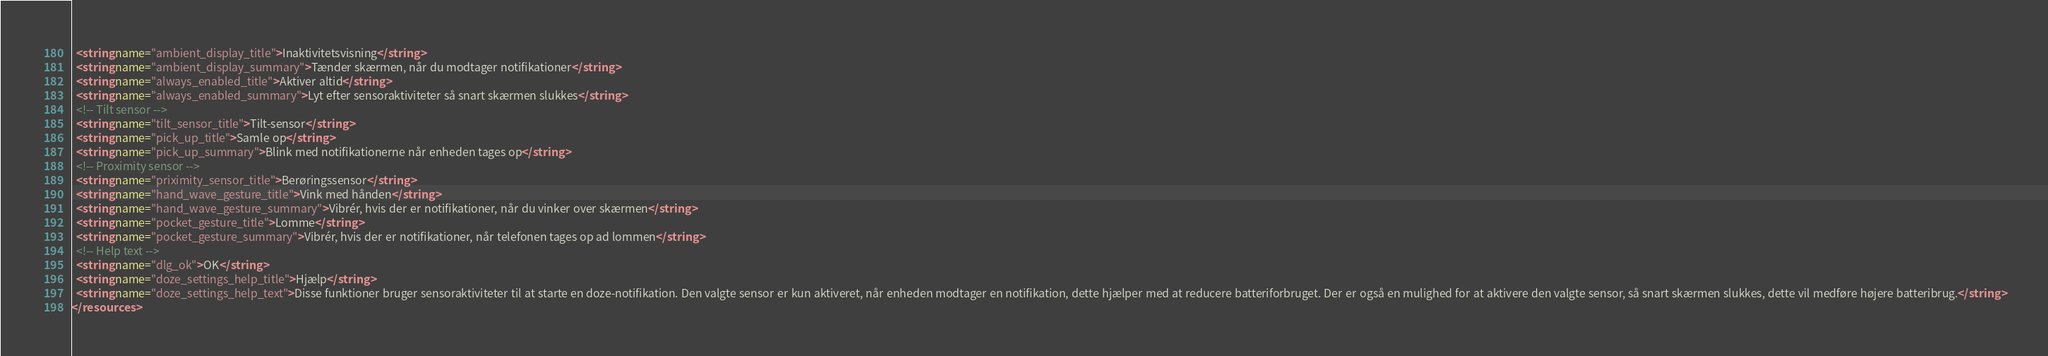Convert code to text. <code><loc_0><loc_0><loc_500><loc_500><_XML_>  <string name="ambient_display_title">Inaktivitetsvisning</string>
  <string name="ambient_display_summary">Tænder skærmen, når du modtager notifikationer</string>
  <string name="always_enabled_title">Aktiver altid</string>
  <string name="always_enabled_summary">Lyt efter sensoraktiviteter så snart skærmen slukkes</string>
  <!-- Tilt sensor -->
  <string name="tilt_sensor_title">Tilt-sensor</string>
  <string name="pick_up_title">Samle op</string>
  <string name="pick_up_summary">Blink med notifikationerne når enheden tages op</string>
  <!-- Proximity sensor -->
  <string name="priximity_sensor_title">Berøringssensor</string>
  <string name="hand_wave_gesture_title">Vink med hånden</string>
  <string name="hand_wave_gesture_summary">Vibrér, hvis der er notifikationer, når du vinker over skærmen</string>
  <string name="pocket_gesture_title">Lomme</string>
  <string name="pocket_gesture_summary">Vibrér, hvis der er notifikationer, når telefonen tages op ad lommen</string>
  <!-- Help text -->
  <string name="dlg_ok">OK</string>
  <string name="doze_settings_help_title">Hjælp</string>
  <string name="doze_settings_help_text">Disse funktioner bruger sensoraktiviteter til at starte en doze-notifikation. Den valgte sensor er kun aktiveret, når enheden modtager en notifikation, dette hjælper med at reducere batteriforbruget. Der er også en mulighed for at aktivere den valgte sensor, så snart skærmen slukkes, dette vil medføre højere batteribrug.</string>
</resources>
</code> 